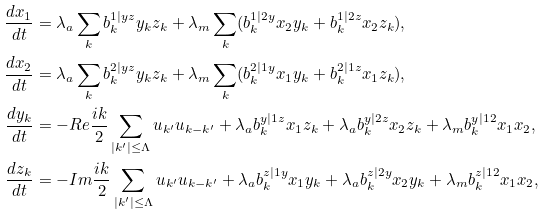<formula> <loc_0><loc_0><loc_500><loc_500>\frac { d x _ { 1 } } { d t } & = \lambda _ { a } \sum _ { k } b _ { k } ^ { 1 | y z } y _ { k } z _ { k } + \lambda _ { m } \sum _ { k } ( b _ { k } ^ { 1 | 2 y } x _ { 2 } y _ { k } + b _ { k } ^ { 1 | 2 z } x _ { 2 } z _ { k } ) , \\ \frac { d x _ { 2 } } { d t } & = \lambda _ { a } \sum _ { k } b _ { k } ^ { 2 | y z } y _ { k } z _ { k } + \lambda _ { m } \sum _ { k } ( b _ { k } ^ { 2 | 1 y } x _ { 1 } y _ { k } + b _ { k } ^ { 2 | 1 z } x _ { 1 } z _ { k } ) , \\ \frac { d y _ { k } } { d t } & = - R e \frac { i k } { 2 } \sum _ { | k ^ { \prime } | \leq \Lambda } u _ { k ^ { \prime } } u _ { k - k ^ { \prime } } + \lambda _ { a } b _ { k } ^ { y | 1 z } x _ { 1 } z _ { k } + \lambda _ { a } b _ { k } ^ { y | 2 z } x _ { 2 } z _ { k } + \lambda _ { m } b _ { k } ^ { y | 1 2 } x _ { 1 } x _ { 2 } , \\ \frac { d z _ { k } } { d t } & = - I m \frac { i k } { 2 } \sum _ { | k ^ { \prime } | \leq \Lambda } u _ { k ^ { \prime } } u _ { k - k ^ { \prime } } + \lambda _ { a } b _ { k } ^ { z | 1 y } x _ { 1 } y _ { k } + \lambda _ { a } b _ { k } ^ { z | 2 y } x _ { 2 } y _ { k } + \lambda _ { m } b _ { k } ^ { z | 1 2 } x _ { 1 } x _ { 2 } ,</formula> 